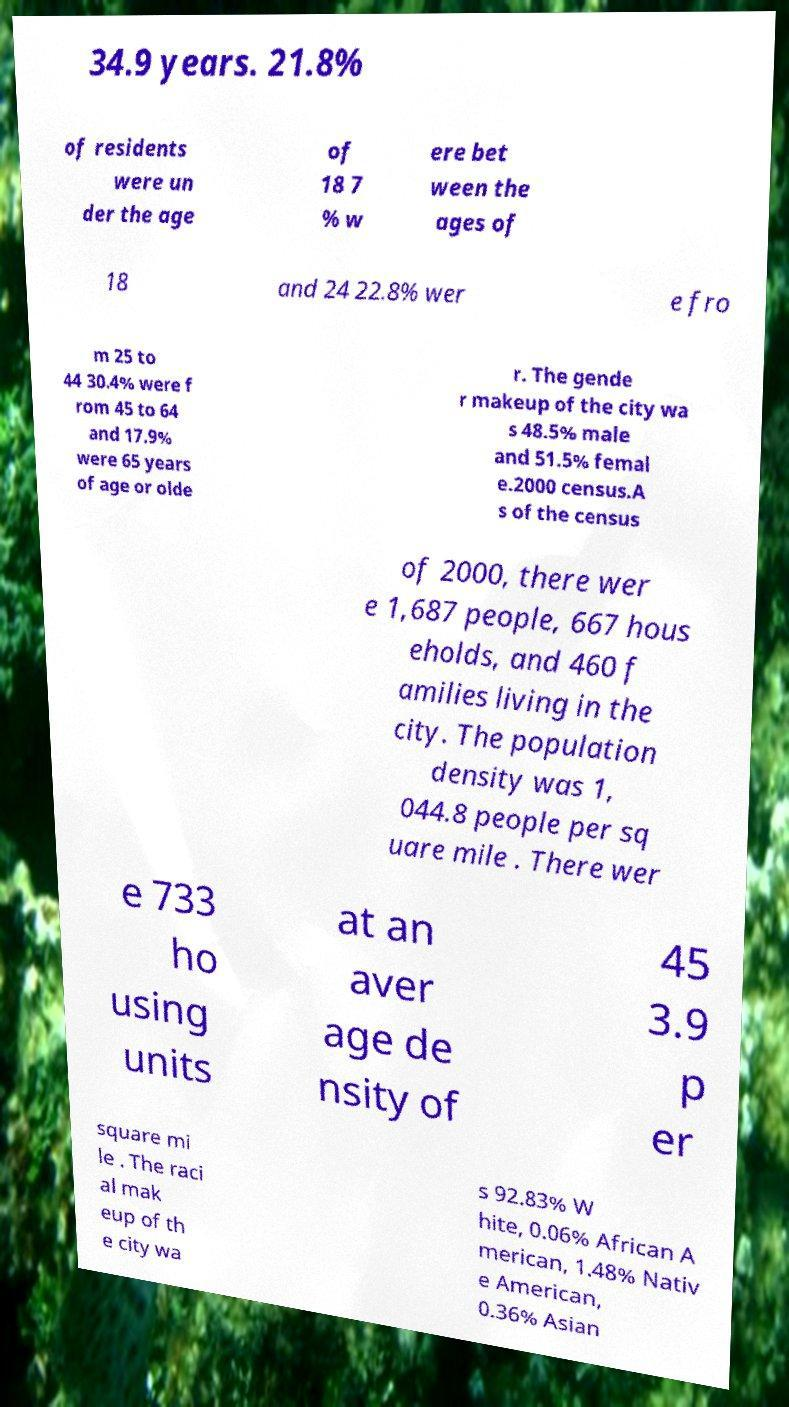What messages or text are displayed in this image? I need them in a readable, typed format. 34.9 years. 21.8% of residents were un der the age of 18 7 % w ere bet ween the ages of 18 and 24 22.8% wer e fro m 25 to 44 30.4% were f rom 45 to 64 and 17.9% were 65 years of age or olde r. The gende r makeup of the city wa s 48.5% male and 51.5% femal e.2000 census.A s of the census of 2000, there wer e 1,687 people, 667 hous eholds, and 460 f amilies living in the city. The population density was 1, 044.8 people per sq uare mile . There wer e 733 ho using units at an aver age de nsity of 45 3.9 p er square mi le . The raci al mak eup of th e city wa s 92.83% W hite, 0.06% African A merican, 1.48% Nativ e American, 0.36% Asian 